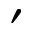Convert formula to latex. <formula><loc_0><loc_0><loc_500><loc_500>^ { \prime }</formula> 